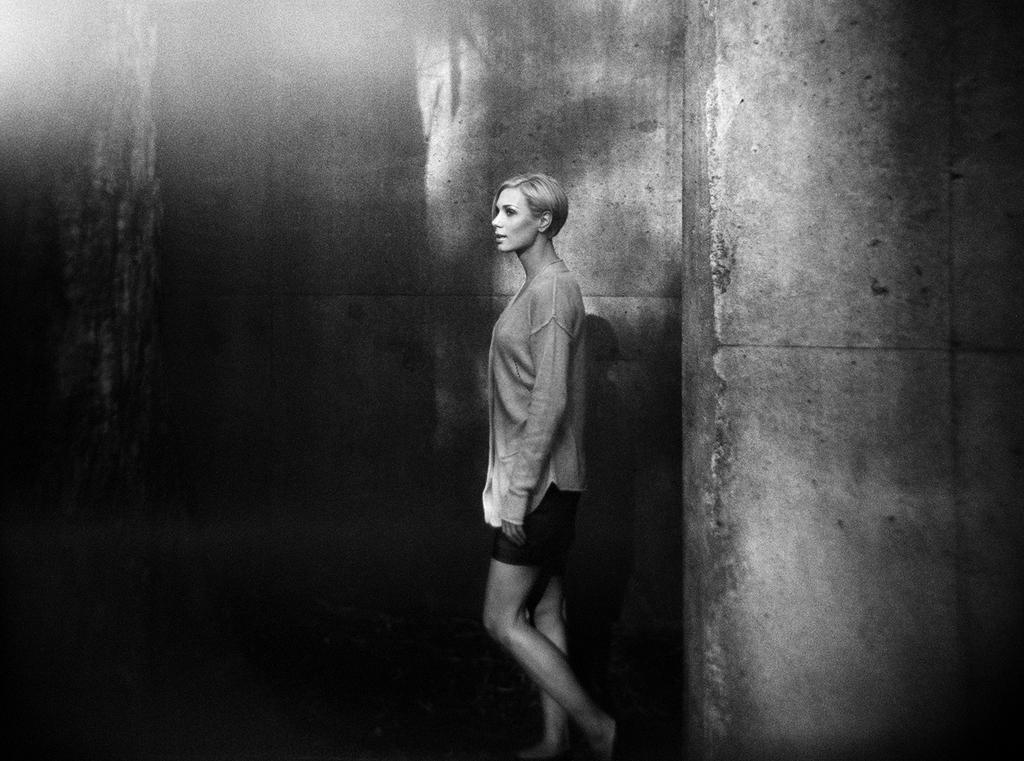Could you give a brief overview of what you see in this image? It is a black and white picture. In the center of the image we can see one person standing. In the background there is a wall. 